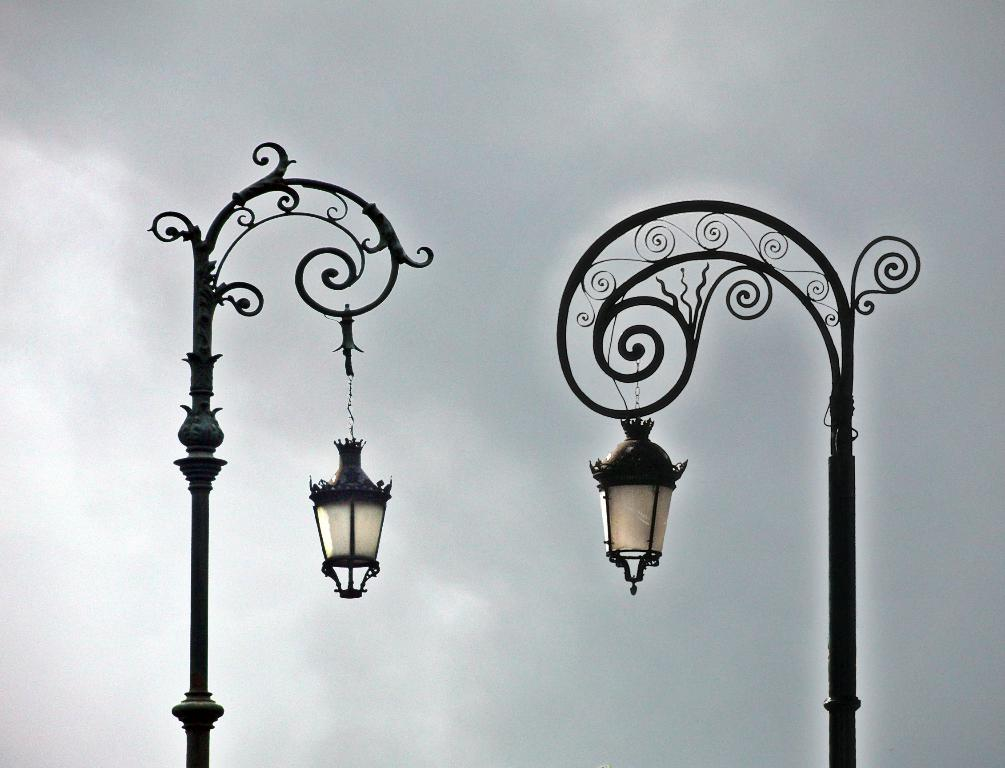What type of poles can be seen in the image? There are designer poles in the image. What is hanging from the poles? Lamps are hanging from the poles. What can be seen in the background of the image? There is a sky visible in the background of the image. What is present in the sky? Clouds are present in the sky. What type of butter can be seen on the poles in the image? There is no butter present on the poles in the image; only lamps are hanging from them. Is there a railway visible in the image? There is no railway present in the image; the focus is on the designer poles and lamps. 